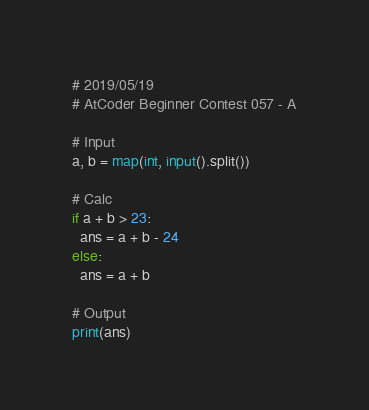Convert code to text. <code><loc_0><loc_0><loc_500><loc_500><_Python_># 2019/05/19
# AtCoder Beginner Contest 057 - A

# Input
a, b = map(int, input().split())

# Calc
if a + b > 23:
  ans = a + b - 24
else:
  ans = a + b

# Output
print(ans)
</code> 